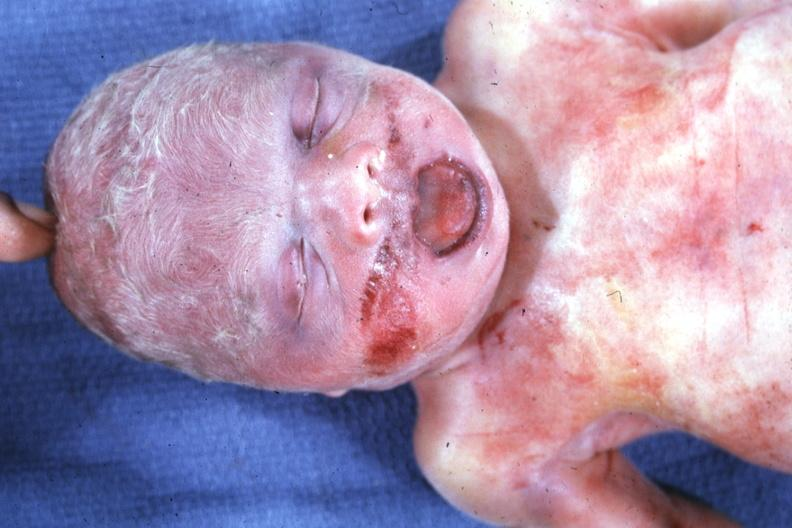s beckwith-wiedemann syndrome present?
Answer the question using a single word or phrase. Yes 